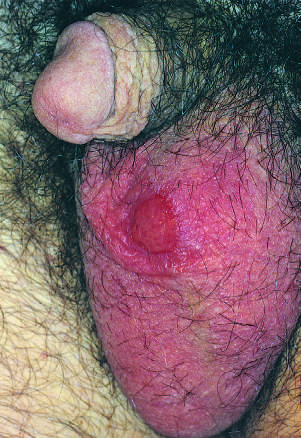re such lesions painless despite the presence of ulceration?
Answer the question using a single word or phrase. Yes 